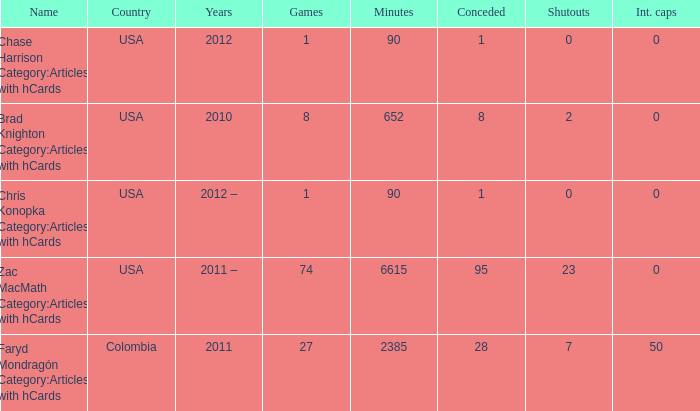When chase harrison category:articles with hcards is the name what is the year? 2012.0. 